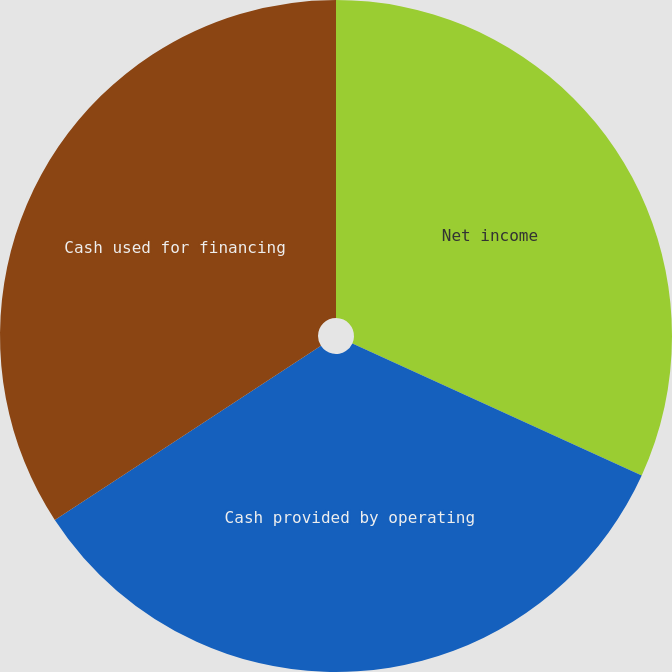Convert chart to OTSL. <chart><loc_0><loc_0><loc_500><loc_500><pie_chart><fcel>Net income<fcel>Cash provided by operating<fcel>Cash used for financing<nl><fcel>31.81%<fcel>33.97%<fcel>34.22%<nl></chart> 